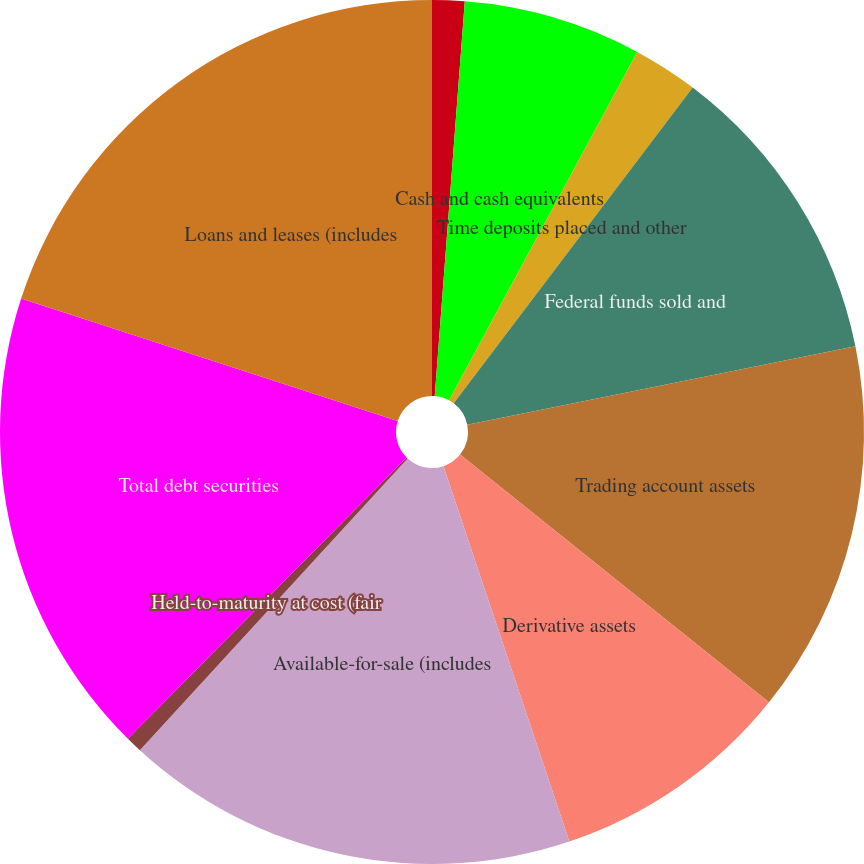<chart> <loc_0><loc_0><loc_500><loc_500><pie_chart><fcel>(Dollars in millions)<fcel>Cash and cash equivalents<fcel>Time deposits placed and other<fcel>Federal funds sold and<fcel>Trading account assets<fcel>Derivative assets<fcel>Available-for-sale (includes<fcel>Held-to-maturity at cost (fair<fcel>Total debt securities<fcel>Loans and leases (includes<nl><fcel>1.21%<fcel>6.67%<fcel>2.43%<fcel>11.51%<fcel>13.94%<fcel>9.09%<fcel>16.97%<fcel>0.61%<fcel>17.57%<fcel>20.0%<nl></chart> 